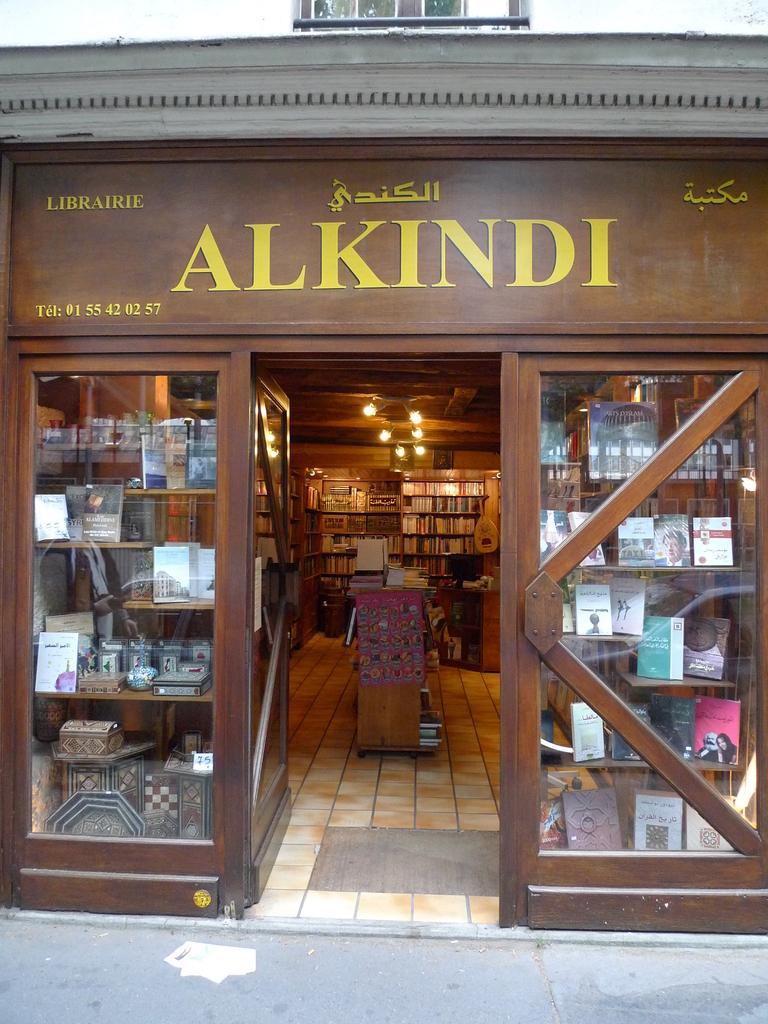What is the name of the store?
Your response must be concise. Alkindi. 